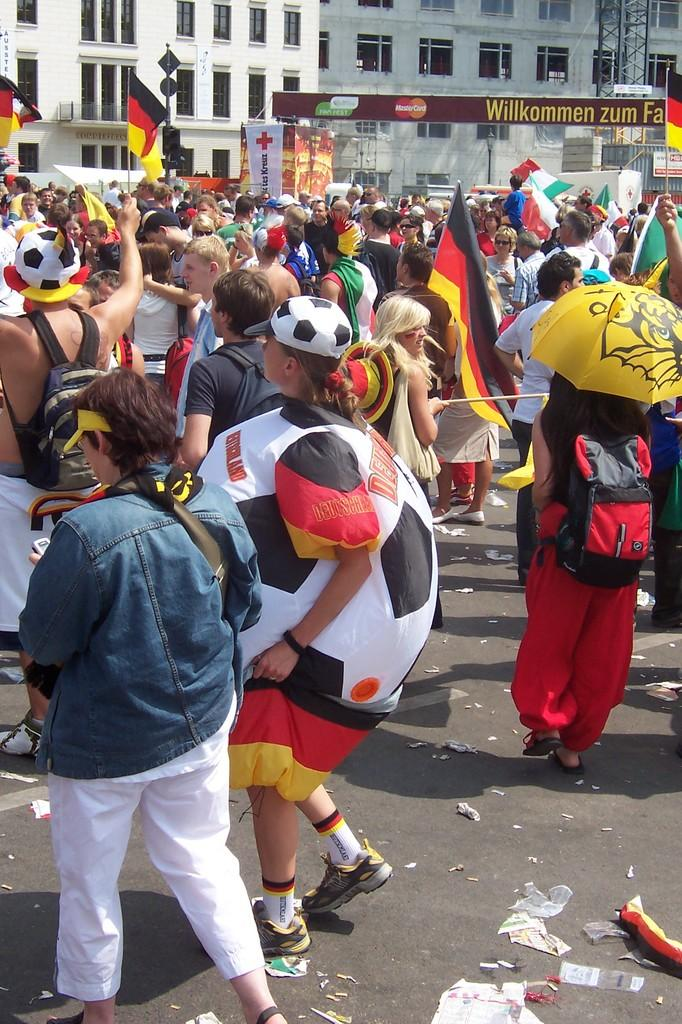How many people are present in the image? There are people in the image, but the exact number is not specified. What can be seen besides people in the image? Flags, hoardings, buildings, a light pole, and sign boards are visible in the image. What are some people holding in the image? Some people are holding flags and umbrellas. What is the purpose of the flags in the image? The purpose of the flags is not specified, but they are being held by some people. What is the function of the light pole in the image? The light pole is likely used for providing illumination, but its specific function is not mentioned. What type of circle is being taught by the person in the image? There is no person teaching a circle in the image, nor is there any indication of a lesson or teaching activity taking place. 